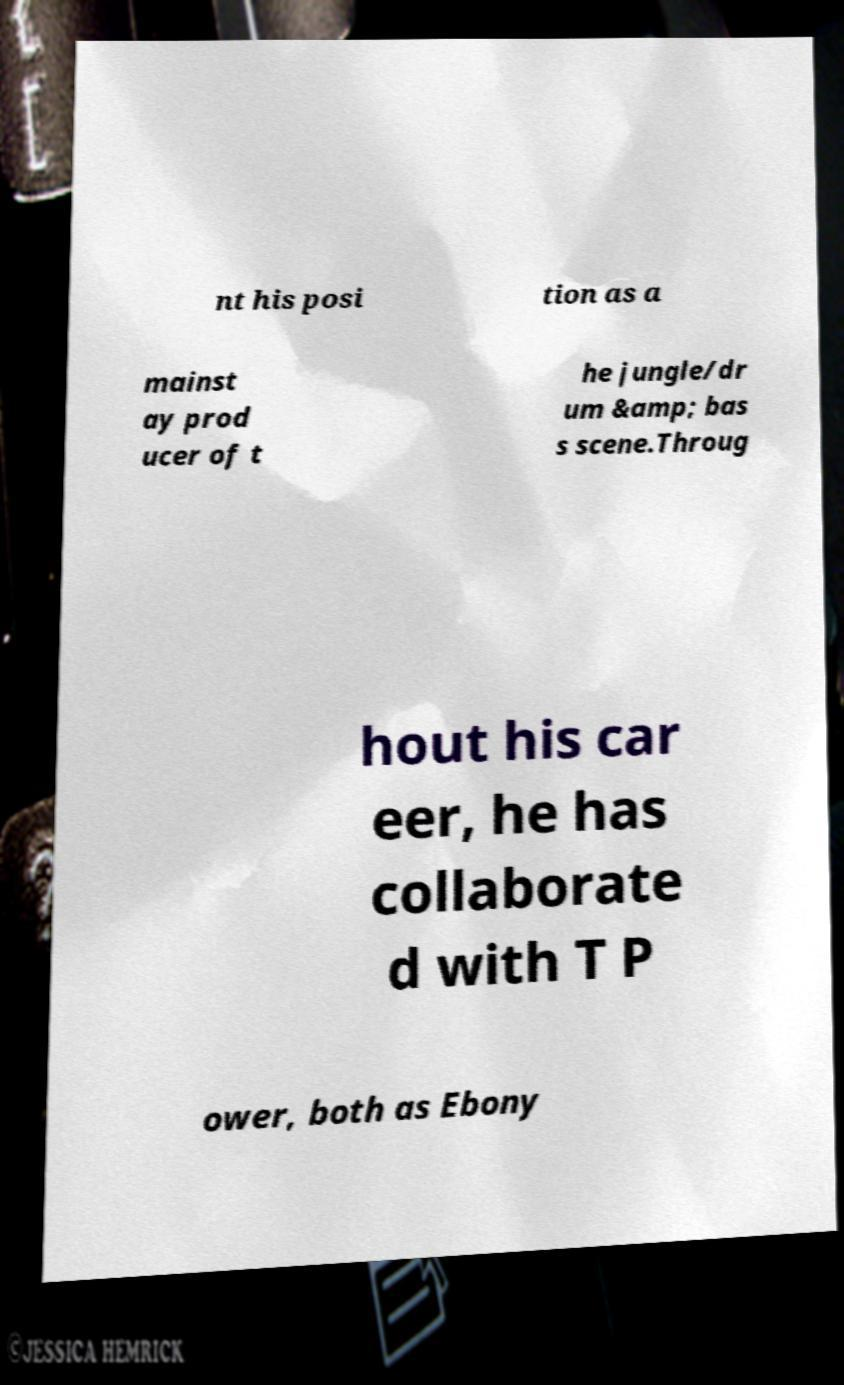Please read and relay the text visible in this image. What does it say? nt his posi tion as a mainst ay prod ucer of t he jungle/dr um &amp; bas s scene.Throug hout his car eer, he has collaborate d with T P ower, both as Ebony 